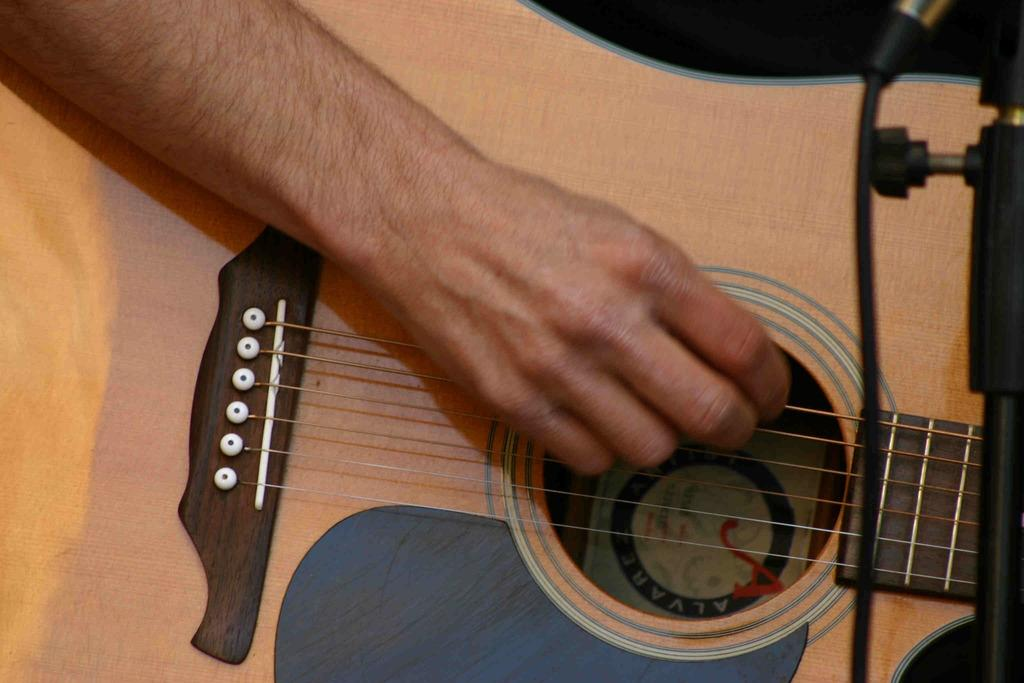What is the human hand in the image doing? The hand is playing a guitar. What other object is present in the image related to music? There is a microphone (mike) in the image. How many nerves can be seen in the image? There are no visible nerves in the image; it features a human hand playing a guitar and a microphone. 